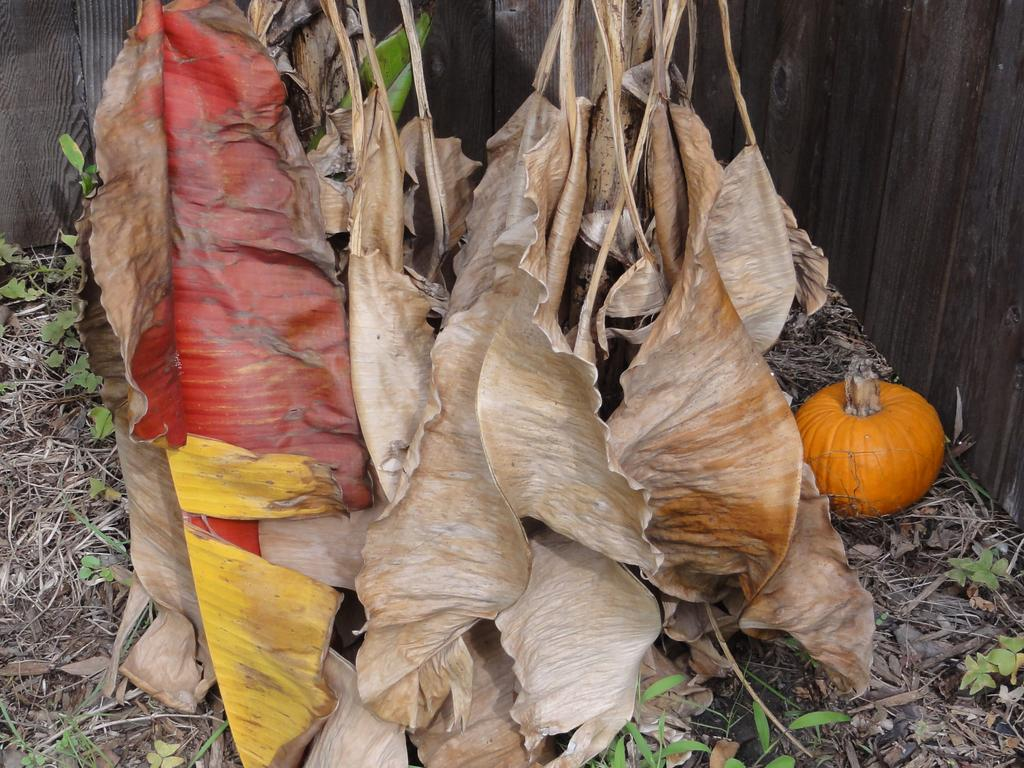What is hanging in the image? There are dry leaves hanging in the image. What else can be seen on the ground in the image? There are plants on the ground in the image. What type of vegetation is visible on the right side of the image? There is a vegetable visible on the right side of the image. What type of cord is used to hang the volleyball in the image? There is no volleyball present in the image, so there is no cord used to hang it. How many apples are visible on the right side of the image? There are no apples present in the image; only a vegetable is visible on the right side. 